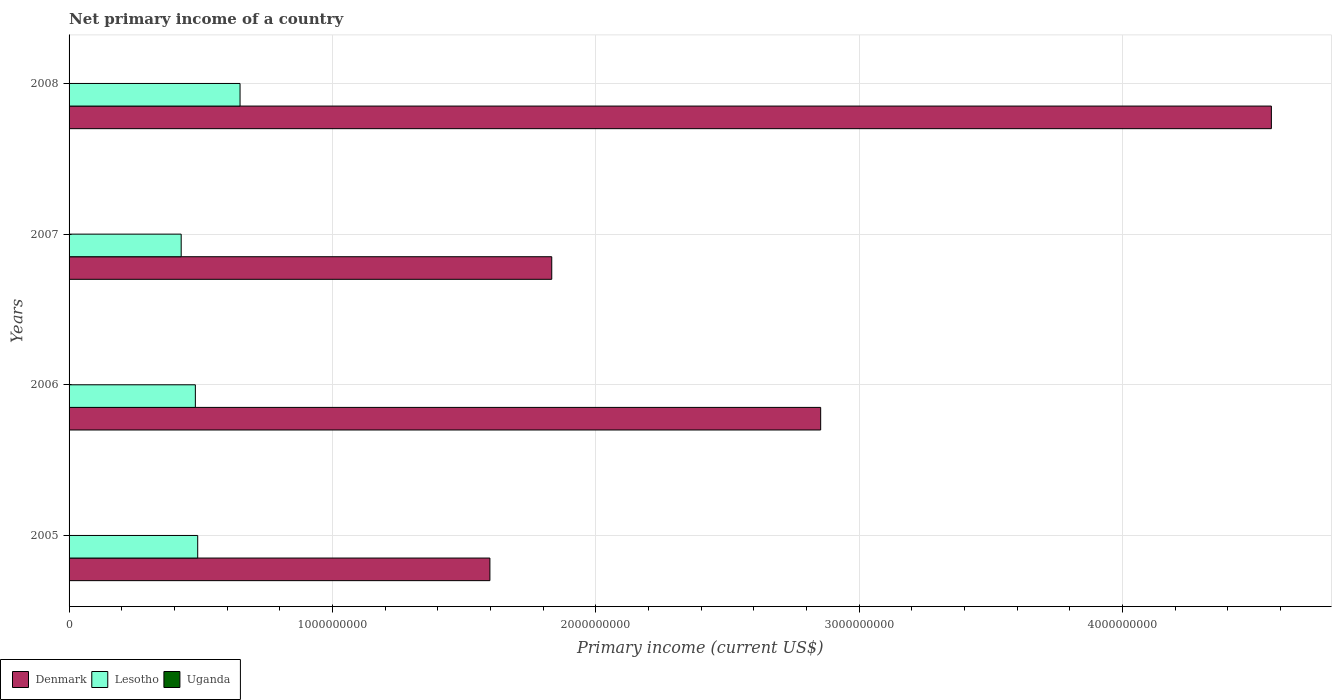How many different coloured bars are there?
Provide a short and direct response. 2. How many groups of bars are there?
Offer a terse response. 4. Are the number of bars on each tick of the Y-axis equal?
Offer a terse response. Yes. How many bars are there on the 1st tick from the top?
Provide a short and direct response. 2. How many bars are there on the 2nd tick from the bottom?
Your answer should be compact. 2. What is the label of the 1st group of bars from the top?
Offer a very short reply. 2008. In how many cases, is the number of bars for a given year not equal to the number of legend labels?
Your answer should be very brief. 4. Across all years, what is the maximum primary income in Lesotho?
Provide a succinct answer. 6.49e+08. Across all years, what is the minimum primary income in Denmark?
Your answer should be compact. 1.60e+09. In which year was the primary income in Lesotho maximum?
Offer a very short reply. 2008. What is the total primary income in Uganda in the graph?
Give a very brief answer. 0. What is the difference between the primary income in Denmark in 2005 and that in 2007?
Provide a succinct answer. -2.35e+08. What is the difference between the primary income in Uganda in 2008 and the primary income in Denmark in 2007?
Make the answer very short. -1.83e+09. What is the average primary income in Denmark per year?
Make the answer very short. 2.71e+09. In the year 2008, what is the difference between the primary income in Denmark and primary income in Lesotho?
Keep it short and to the point. 3.92e+09. In how many years, is the primary income in Lesotho greater than 3200000000 US$?
Your answer should be very brief. 0. What is the ratio of the primary income in Denmark in 2006 to that in 2007?
Your answer should be compact. 1.56. Is the difference between the primary income in Denmark in 2005 and 2006 greater than the difference between the primary income in Lesotho in 2005 and 2006?
Your answer should be very brief. No. What is the difference between the highest and the second highest primary income in Denmark?
Give a very brief answer. 1.71e+09. What is the difference between the highest and the lowest primary income in Denmark?
Keep it short and to the point. 2.97e+09. In how many years, is the primary income in Uganda greater than the average primary income in Uganda taken over all years?
Give a very brief answer. 0. Is it the case that in every year, the sum of the primary income in Denmark and primary income in Lesotho is greater than the primary income in Uganda?
Give a very brief answer. Yes. What is the difference between two consecutive major ticks on the X-axis?
Give a very brief answer. 1.00e+09. Are the values on the major ticks of X-axis written in scientific E-notation?
Give a very brief answer. No. Does the graph contain any zero values?
Offer a terse response. Yes. Where does the legend appear in the graph?
Keep it short and to the point. Bottom left. What is the title of the graph?
Your answer should be very brief. Net primary income of a country. What is the label or title of the X-axis?
Your answer should be compact. Primary income (current US$). What is the Primary income (current US$) of Denmark in 2005?
Offer a terse response. 1.60e+09. What is the Primary income (current US$) in Lesotho in 2005?
Offer a very short reply. 4.88e+08. What is the Primary income (current US$) in Uganda in 2005?
Your answer should be very brief. 0. What is the Primary income (current US$) in Denmark in 2006?
Your answer should be very brief. 2.85e+09. What is the Primary income (current US$) in Lesotho in 2006?
Ensure brevity in your answer.  4.79e+08. What is the Primary income (current US$) in Denmark in 2007?
Offer a very short reply. 1.83e+09. What is the Primary income (current US$) of Lesotho in 2007?
Offer a very short reply. 4.26e+08. What is the Primary income (current US$) of Denmark in 2008?
Provide a succinct answer. 4.56e+09. What is the Primary income (current US$) in Lesotho in 2008?
Offer a terse response. 6.49e+08. Across all years, what is the maximum Primary income (current US$) in Denmark?
Provide a succinct answer. 4.56e+09. Across all years, what is the maximum Primary income (current US$) in Lesotho?
Give a very brief answer. 6.49e+08. Across all years, what is the minimum Primary income (current US$) in Denmark?
Offer a terse response. 1.60e+09. Across all years, what is the minimum Primary income (current US$) in Lesotho?
Provide a succinct answer. 4.26e+08. What is the total Primary income (current US$) in Denmark in the graph?
Provide a short and direct response. 1.08e+1. What is the total Primary income (current US$) of Lesotho in the graph?
Offer a very short reply. 2.04e+09. What is the total Primary income (current US$) in Uganda in the graph?
Your response must be concise. 0. What is the difference between the Primary income (current US$) of Denmark in 2005 and that in 2006?
Your response must be concise. -1.26e+09. What is the difference between the Primary income (current US$) of Lesotho in 2005 and that in 2006?
Keep it short and to the point. 8.88e+06. What is the difference between the Primary income (current US$) in Denmark in 2005 and that in 2007?
Keep it short and to the point. -2.35e+08. What is the difference between the Primary income (current US$) of Lesotho in 2005 and that in 2007?
Your answer should be compact. 6.27e+07. What is the difference between the Primary income (current US$) of Denmark in 2005 and that in 2008?
Make the answer very short. -2.97e+09. What is the difference between the Primary income (current US$) in Lesotho in 2005 and that in 2008?
Offer a terse response. -1.61e+08. What is the difference between the Primary income (current US$) in Denmark in 2006 and that in 2007?
Your answer should be compact. 1.02e+09. What is the difference between the Primary income (current US$) of Lesotho in 2006 and that in 2007?
Give a very brief answer. 5.38e+07. What is the difference between the Primary income (current US$) of Denmark in 2006 and that in 2008?
Your answer should be very brief. -1.71e+09. What is the difference between the Primary income (current US$) in Lesotho in 2006 and that in 2008?
Give a very brief answer. -1.70e+08. What is the difference between the Primary income (current US$) of Denmark in 2007 and that in 2008?
Offer a very short reply. -2.73e+09. What is the difference between the Primary income (current US$) in Lesotho in 2007 and that in 2008?
Offer a very short reply. -2.23e+08. What is the difference between the Primary income (current US$) in Denmark in 2005 and the Primary income (current US$) in Lesotho in 2006?
Your response must be concise. 1.12e+09. What is the difference between the Primary income (current US$) of Denmark in 2005 and the Primary income (current US$) of Lesotho in 2007?
Offer a terse response. 1.17e+09. What is the difference between the Primary income (current US$) in Denmark in 2005 and the Primary income (current US$) in Lesotho in 2008?
Your answer should be compact. 9.49e+08. What is the difference between the Primary income (current US$) of Denmark in 2006 and the Primary income (current US$) of Lesotho in 2007?
Your response must be concise. 2.43e+09. What is the difference between the Primary income (current US$) of Denmark in 2006 and the Primary income (current US$) of Lesotho in 2008?
Provide a short and direct response. 2.20e+09. What is the difference between the Primary income (current US$) of Denmark in 2007 and the Primary income (current US$) of Lesotho in 2008?
Offer a terse response. 1.18e+09. What is the average Primary income (current US$) in Denmark per year?
Your response must be concise. 2.71e+09. What is the average Primary income (current US$) in Lesotho per year?
Your response must be concise. 5.11e+08. In the year 2005, what is the difference between the Primary income (current US$) of Denmark and Primary income (current US$) of Lesotho?
Your response must be concise. 1.11e+09. In the year 2006, what is the difference between the Primary income (current US$) of Denmark and Primary income (current US$) of Lesotho?
Offer a very short reply. 2.37e+09. In the year 2007, what is the difference between the Primary income (current US$) of Denmark and Primary income (current US$) of Lesotho?
Your answer should be compact. 1.41e+09. In the year 2008, what is the difference between the Primary income (current US$) in Denmark and Primary income (current US$) in Lesotho?
Make the answer very short. 3.92e+09. What is the ratio of the Primary income (current US$) of Denmark in 2005 to that in 2006?
Give a very brief answer. 0.56. What is the ratio of the Primary income (current US$) in Lesotho in 2005 to that in 2006?
Your answer should be compact. 1.02. What is the ratio of the Primary income (current US$) of Denmark in 2005 to that in 2007?
Offer a terse response. 0.87. What is the ratio of the Primary income (current US$) of Lesotho in 2005 to that in 2007?
Offer a terse response. 1.15. What is the ratio of the Primary income (current US$) of Lesotho in 2005 to that in 2008?
Keep it short and to the point. 0.75. What is the ratio of the Primary income (current US$) in Denmark in 2006 to that in 2007?
Offer a terse response. 1.56. What is the ratio of the Primary income (current US$) of Lesotho in 2006 to that in 2007?
Keep it short and to the point. 1.13. What is the ratio of the Primary income (current US$) in Denmark in 2006 to that in 2008?
Offer a terse response. 0.63. What is the ratio of the Primary income (current US$) of Lesotho in 2006 to that in 2008?
Offer a terse response. 0.74. What is the ratio of the Primary income (current US$) of Denmark in 2007 to that in 2008?
Keep it short and to the point. 0.4. What is the ratio of the Primary income (current US$) in Lesotho in 2007 to that in 2008?
Provide a succinct answer. 0.66. What is the difference between the highest and the second highest Primary income (current US$) of Denmark?
Offer a terse response. 1.71e+09. What is the difference between the highest and the second highest Primary income (current US$) in Lesotho?
Provide a short and direct response. 1.61e+08. What is the difference between the highest and the lowest Primary income (current US$) in Denmark?
Offer a very short reply. 2.97e+09. What is the difference between the highest and the lowest Primary income (current US$) in Lesotho?
Offer a very short reply. 2.23e+08. 